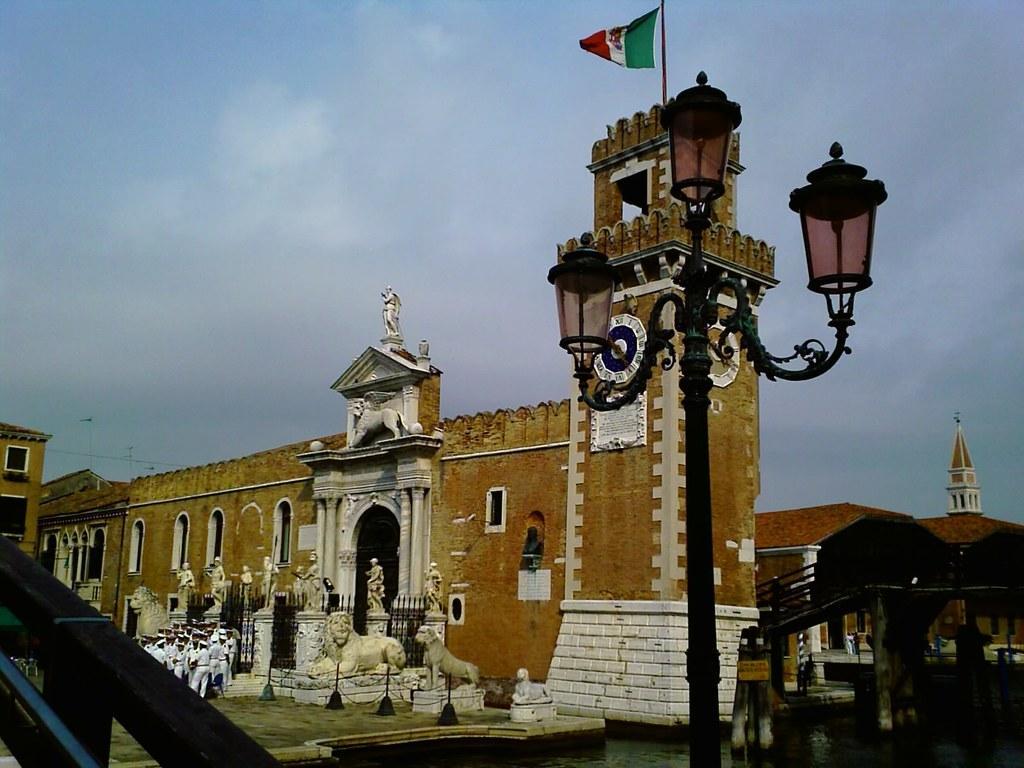Could you give a brief overview of what you see in this image? In this image we can see a monument. On the top of the monument flag is there. In front of the monument statues are there and people are standing. At the top of the image sky is there with some clouds. we can see one light pole which is in black color. 